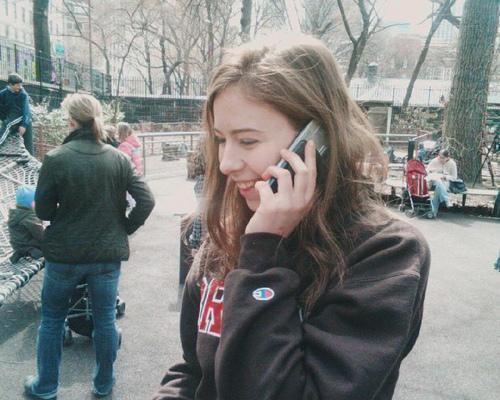How many people are there?
Give a very brief answer. 2. 